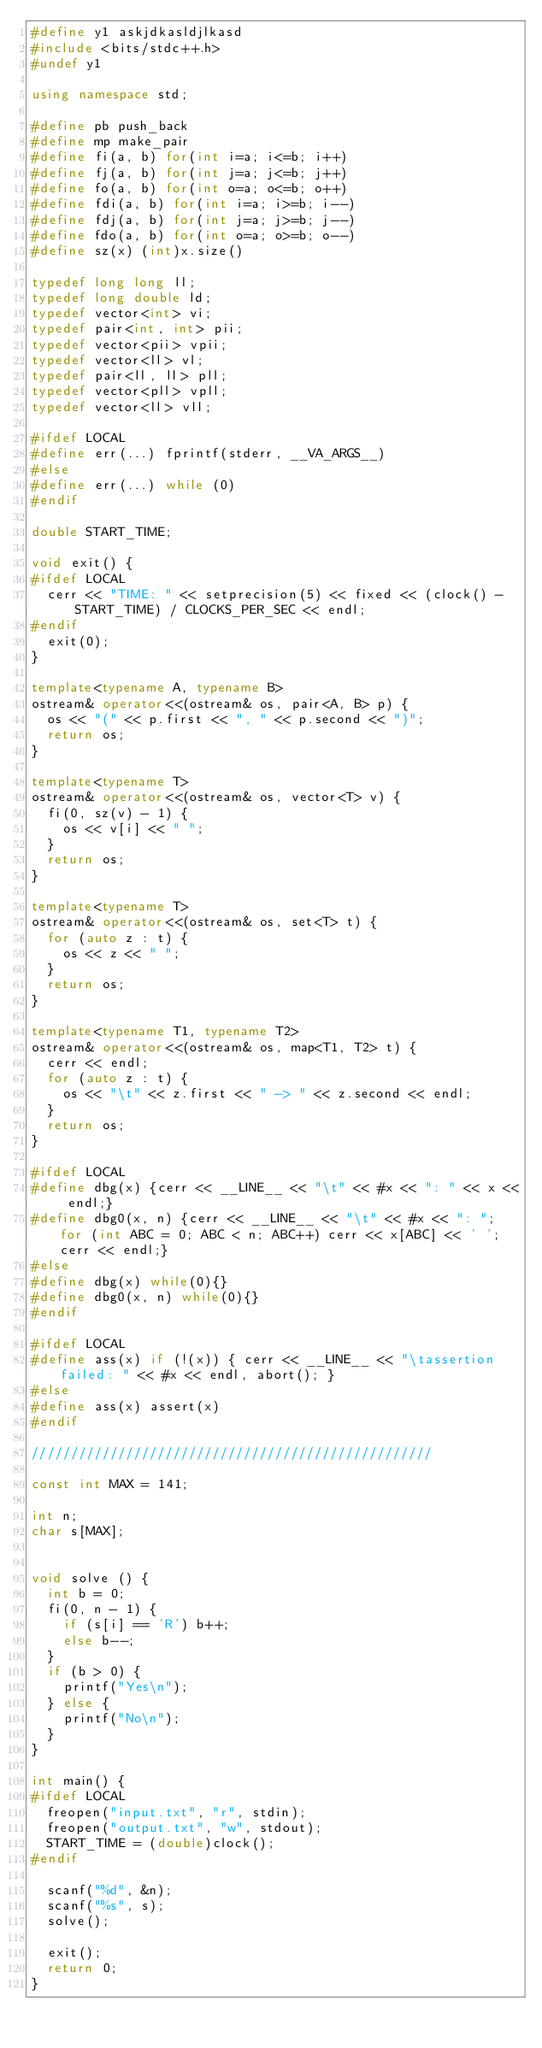<code> <loc_0><loc_0><loc_500><loc_500><_C++_>#define y1 askjdkasldjlkasd
#include <bits/stdc++.h>
#undef y1

using namespace std;

#define pb push_back
#define mp make_pair
#define fi(a, b) for(int i=a; i<=b; i++)
#define fj(a, b) for(int j=a; j<=b; j++)
#define fo(a, b) for(int o=a; o<=b; o++)
#define fdi(a, b) for(int i=a; i>=b; i--)
#define fdj(a, b) for(int j=a; j>=b; j--)
#define fdo(a, b) for(int o=a; o>=b; o--)
#define sz(x) (int)x.size()

typedef long long ll;
typedef long double ld;
typedef vector<int> vi;
typedef pair<int, int> pii;
typedef vector<pii> vpii;
typedef vector<ll> vl;
typedef pair<ll, ll> pll;
typedef vector<pll> vpll;
typedef vector<ll> vll;

#ifdef LOCAL
#define err(...) fprintf(stderr, __VA_ARGS__)
#else
#define err(...) while (0)
#endif

double START_TIME;

void exit() {
#ifdef LOCAL	
	cerr << "TIME: " << setprecision(5) << fixed << (clock() - START_TIME) / CLOCKS_PER_SEC << endl;
#endif	
	exit(0);
}

template<typename A, typename B>
ostream& operator<<(ostream& os, pair<A, B> p) {
	os << "(" << p.first << ", " << p.second << ")";
	return os;
}

template<typename T>
ostream& operator<<(ostream& os, vector<T> v) {
	fi(0, sz(v) - 1) {
		os << v[i] << " ";
	}
	return os;
}

template<typename T>
ostream& operator<<(ostream& os, set<T> t) {
	for (auto z : t) {
		os << z << " ";
	}
	return os;
}

template<typename T1, typename T2>
ostream& operator<<(ostream& os, map<T1, T2> t) {
	cerr << endl;
	for (auto z : t) {
		os << "\t" << z.first << " -> " << z.second << endl;
	}
	return os;
}

#ifdef LOCAL
#define dbg(x) {cerr << __LINE__ << "\t" << #x << ": " << x << endl;}
#define dbg0(x, n) {cerr << __LINE__ << "\t" << #x << ": "; for (int ABC = 0; ABC < n; ABC++) cerr << x[ABC] << ' '; cerr << endl;}
#else
#define dbg(x) while(0){}
#define dbg0(x, n) while(0){}
#endif

#ifdef LOCAL
#define ass(x) if (!(x)) { cerr << __LINE__ << "\tassertion failed: " << #x << endl, abort(); }
#else
#define ass(x) assert(x)
#endif

///////////////////////////////////////////////////

const int MAX = 141;

int n;
char s[MAX];


void solve () {
	int b = 0;
	fi(0, n - 1) {
		if (s[i] == 'R') b++;
		else b--;
	}
	if (b > 0) {
		printf("Yes\n");
	} else {
		printf("No\n");
	}
}

int main() {
#ifdef LOCAL
	freopen("input.txt", "r", stdin);
	freopen("output.txt", "w", stdout);
	START_TIME = (double)clock();
#endif
		
	scanf("%d", &n);
	scanf("%s", s);
	solve();

	exit();
	return 0;
}



</code> 